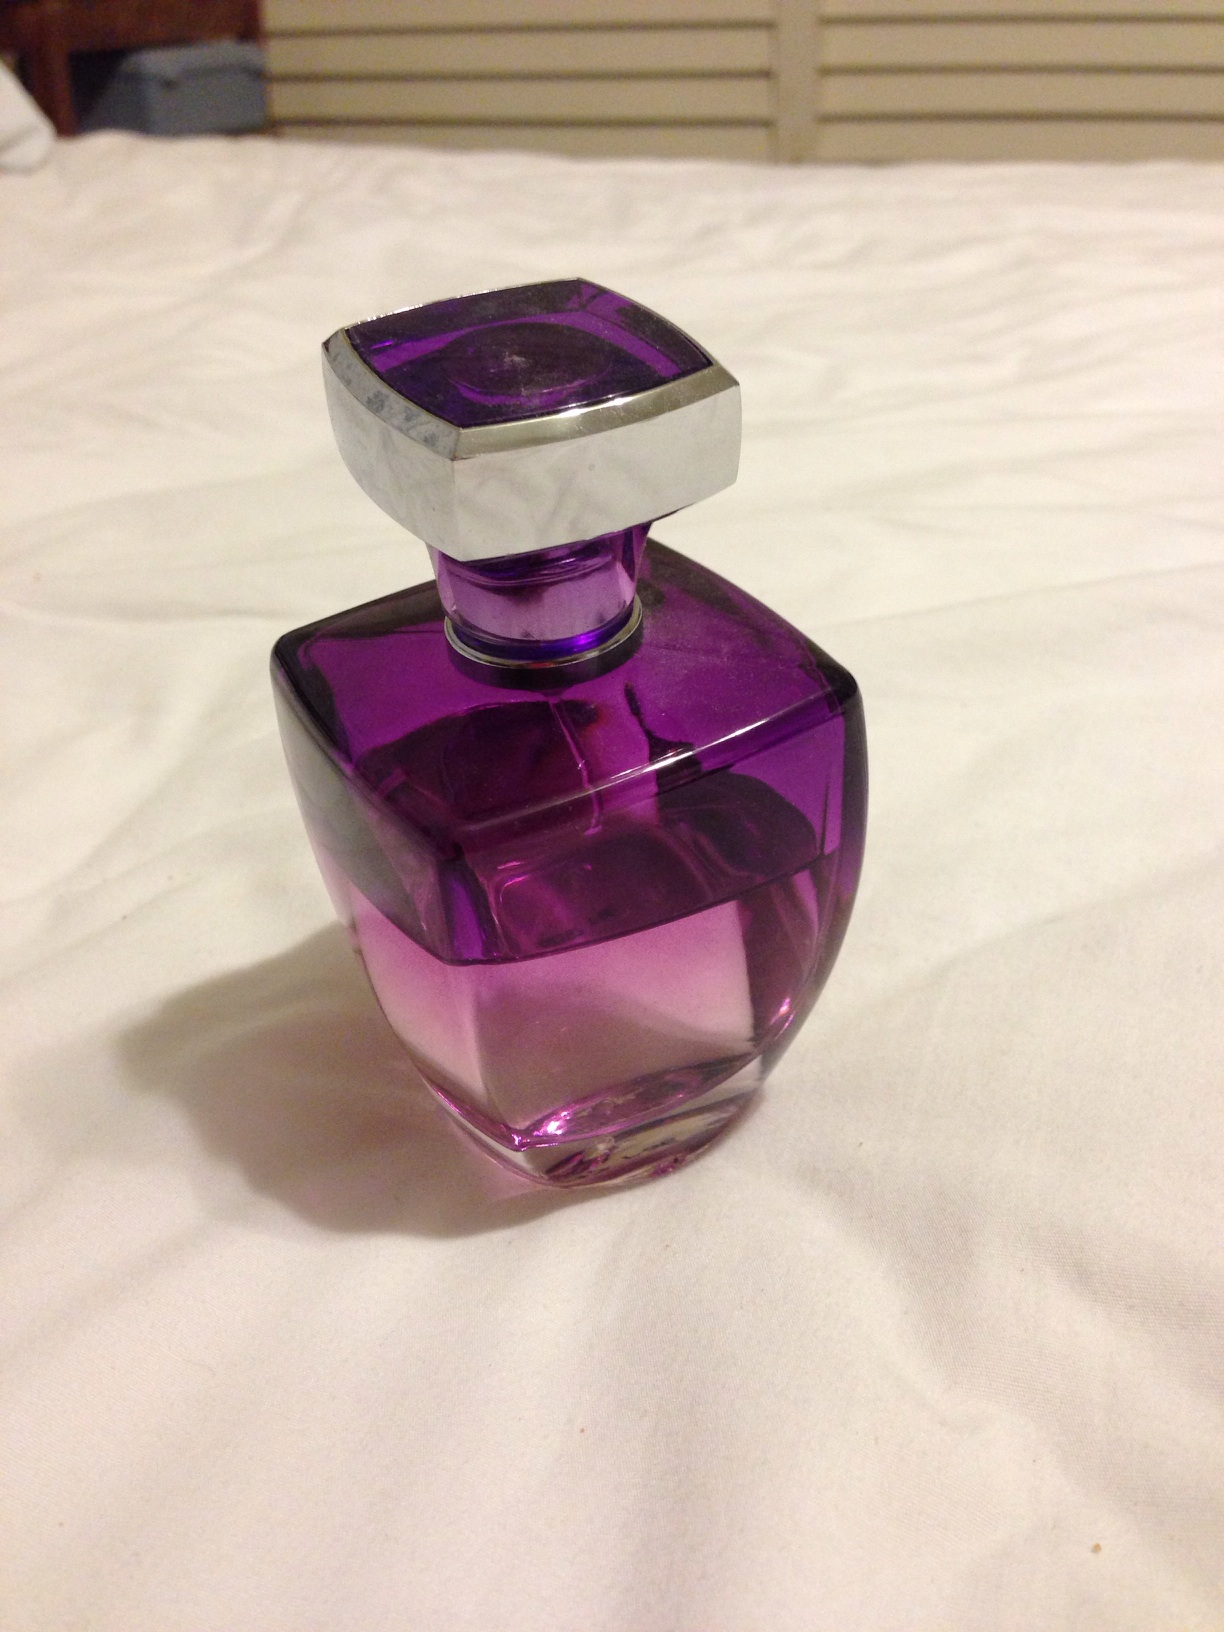What is it? This image depicts a stylish bottle of perfume, characterized by its vibrant purple color and distinctive geometric shaped cap, likely indicating a modern and possibly luxurious brand. 